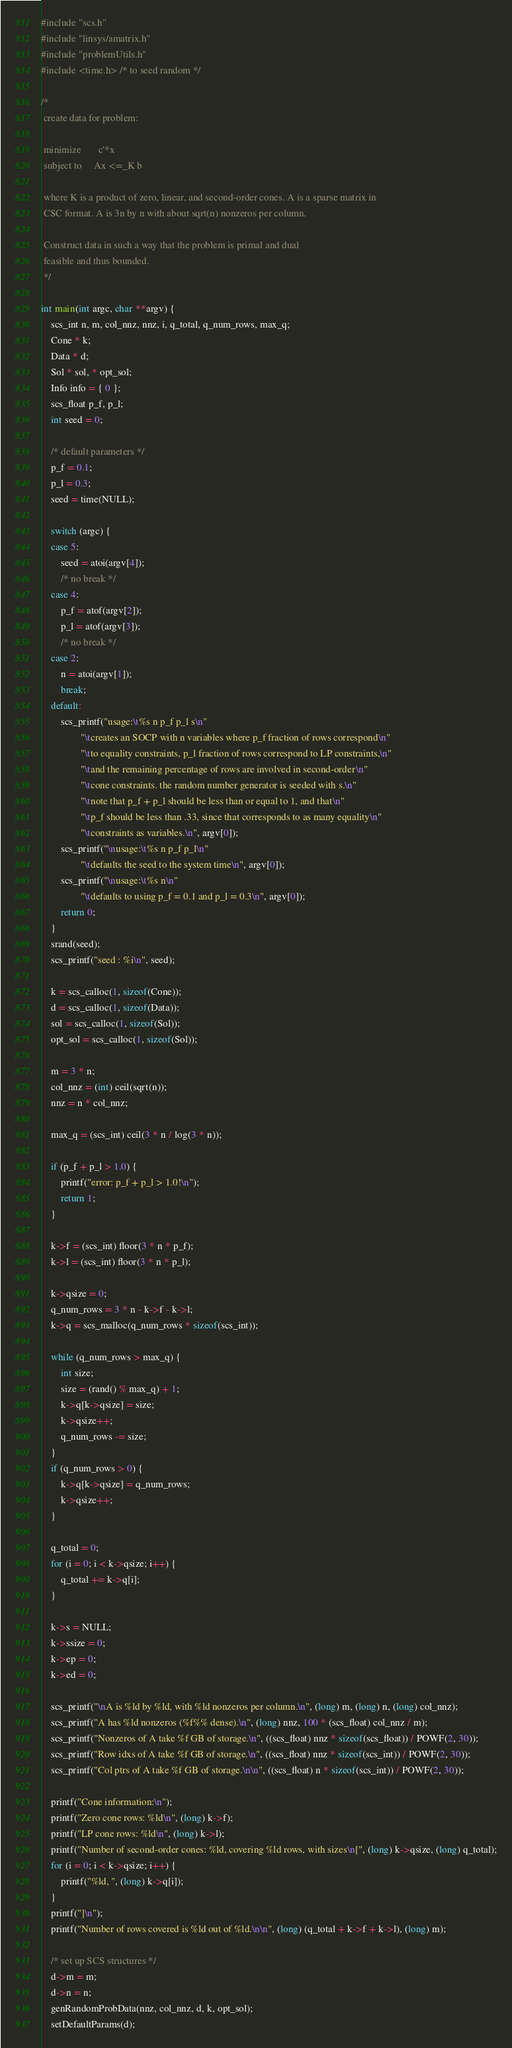<code> <loc_0><loc_0><loc_500><loc_500><_C_>#include "scs.h"
#include "linsys/amatrix.h"
#include "problemUtils.h"
#include <time.h> /* to seed random */

/*
 create data for problem:

 minimize 	    c'*x
 subject to 	Ax <=_K b

 where K is a product of zero, linear, and second-order cones. A is a sparse matrix in
 CSC format. A is 3n by n with about sqrt(n) nonzeros per column.

 Construct data in such a way that the problem is primal and dual
 feasible and thus bounded.
 */

int main(int argc, char **argv) {
	scs_int n, m, col_nnz, nnz, i, q_total, q_num_rows, max_q;
	Cone * k;
	Data * d;
	Sol * sol, * opt_sol;
	Info info = { 0 };
	scs_float p_f, p_l;
	int seed = 0;

	/* default parameters */
	p_f = 0.1;
	p_l = 0.3;
	seed = time(NULL);

	switch (argc) {
	case 5:
		seed = atoi(argv[4]);
		/* no break */
	case 4:
		p_f = atof(argv[2]);
		p_l = atof(argv[3]);
		/* no break */
	case 2:
		n = atoi(argv[1]);
		break;
	default:
		scs_printf("usage:\t%s n p_f p_l s\n"
				"\tcreates an SOCP with n variables where p_f fraction of rows correspond\n"
				"\tto equality constraints, p_l fraction of rows correspond to LP constraints,\n"
				"\tand the remaining percentage of rows are involved in second-order\n"
				"\tcone constraints. the random number generator is seeded with s.\n"
				"\tnote that p_f + p_l should be less than or equal to 1, and that\n"
				"\tp_f should be less than .33, since that corresponds to as many equality\n"
				"\tconstraints as variables.\n", argv[0]);
		scs_printf("\nusage:\t%s n p_f p_l\n"
				"\tdefaults the seed to the system time\n", argv[0]);
		scs_printf("\nusage:\t%s n\n"
				"\tdefaults to using p_f = 0.1 and p_l = 0.3\n", argv[0]);
		return 0;
	}
	srand(seed);
	scs_printf("seed : %i\n", seed);

	k = scs_calloc(1, sizeof(Cone));
	d = scs_calloc(1, sizeof(Data));
	sol = scs_calloc(1, sizeof(Sol));
	opt_sol = scs_calloc(1, sizeof(Sol));

	m = 3 * n;
	col_nnz = (int) ceil(sqrt(n));
	nnz = n * col_nnz;

	max_q = (scs_int) ceil(3 * n / log(3 * n));

	if (p_f + p_l > 1.0) {
		printf("error: p_f + p_l > 1.0!\n");
		return 1;
	}

	k->f = (scs_int) floor(3 * n * p_f);
	k->l = (scs_int) floor(3 * n * p_l);

	k->qsize = 0;
	q_num_rows = 3 * n - k->f - k->l;
	k->q = scs_malloc(q_num_rows * sizeof(scs_int));

	while (q_num_rows > max_q) {
		int size;
		size = (rand() % max_q) + 1;
		k->q[k->qsize] = size;
		k->qsize++;
		q_num_rows -= size;
	}
	if (q_num_rows > 0) {
		k->q[k->qsize] = q_num_rows;
		k->qsize++;
	}

	q_total = 0;
	for (i = 0; i < k->qsize; i++) {
		q_total += k->q[i];
	}

	k->s = NULL;
	k->ssize = 0;
	k->ep = 0;
	k->ed = 0;

	scs_printf("\nA is %ld by %ld, with %ld nonzeros per column.\n", (long) m, (long) n, (long) col_nnz);
	scs_printf("A has %ld nonzeros (%f%% dense).\n", (long) nnz, 100 * (scs_float) col_nnz / m);
	scs_printf("Nonzeros of A take %f GB of storage.\n", ((scs_float) nnz * sizeof(scs_float)) / POWF(2, 30));
	scs_printf("Row idxs of A take %f GB of storage.\n", ((scs_float) nnz * sizeof(scs_int)) / POWF(2, 30));
	scs_printf("Col ptrs of A take %f GB of storage.\n\n", ((scs_float) n * sizeof(scs_int)) / POWF(2, 30));

	printf("Cone information:\n");
	printf("Zero cone rows: %ld\n", (long) k->f);
	printf("LP cone rows: %ld\n", (long) k->l);
	printf("Number of second-order cones: %ld, covering %ld rows, with sizes\n[", (long) k->qsize, (long) q_total);
	for (i = 0; i < k->qsize; i++) {
		printf("%ld, ", (long) k->q[i]);
	}
	printf("]\n");
	printf("Number of rows covered is %ld out of %ld.\n\n", (long) (q_total + k->f + k->l), (long) m);

	/* set up SCS structures */
	d->m = m;
	d->n = n;
	genRandomProbData(nnz, col_nnz, d, k, opt_sol);
	setDefaultParams(d);
</code> 